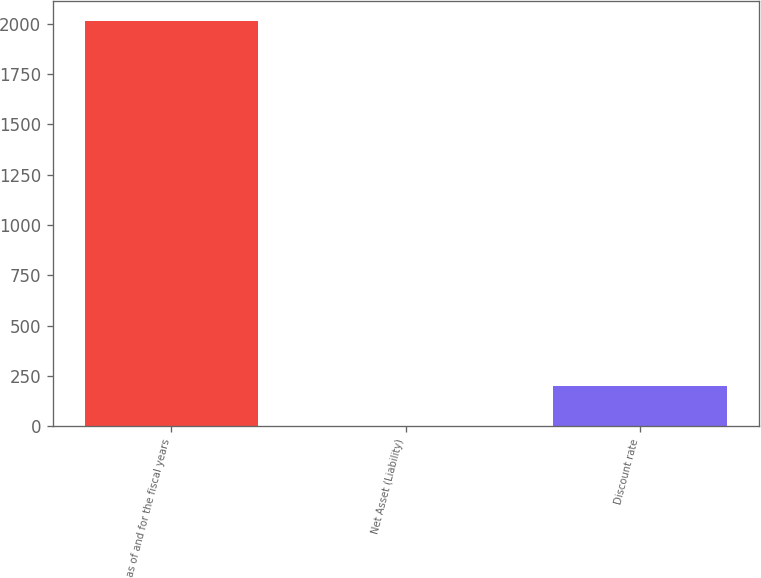Convert chart. <chart><loc_0><loc_0><loc_500><loc_500><bar_chart><fcel>as of and for the fiscal years<fcel>Net Asset (Liability)<fcel>Discount rate<nl><fcel>2013<fcel>0.3<fcel>201.57<nl></chart> 